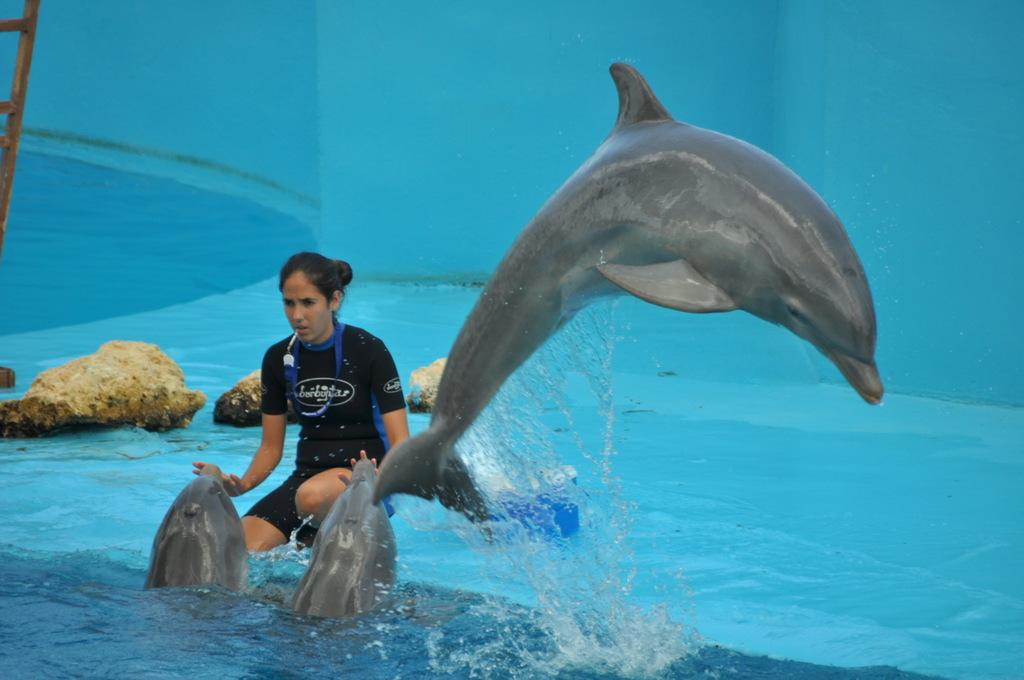Who is the main subject in the image? There is a woman in the image. What is the woman doing in the image? The woman is playing with dolphins. What can be seen in the background of the image? There are rocks visible in the background of the image. What color is the background of the image? The background of the image is blue. How many sisters are playing with the dolphins in the image? There is no mention of sisters in the image; the main subject is a woman playing with dolphins. 